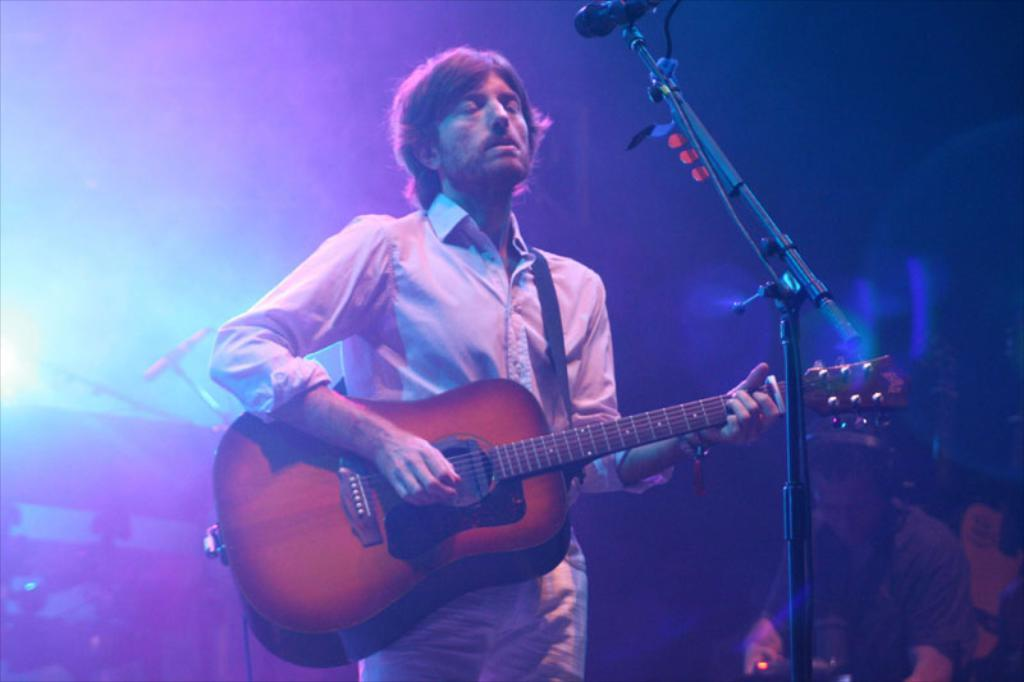What is the man in the image doing? The man is playing a guitar in the image. What is the man wearing? The man is wearing a white shirt in the image. What is the setting of the image? The setting is a studio. What can be seen beside the man playing the guitar? There is another man beside him in the image. What is the second man wearing? The second man is wearing headphones in the image. What is the second man doing? The second man is listening to the first man's song in the image. What type of ice can be seen melting on the guitar in the image? There is no ice present in the image, and the guitar is not melting. 